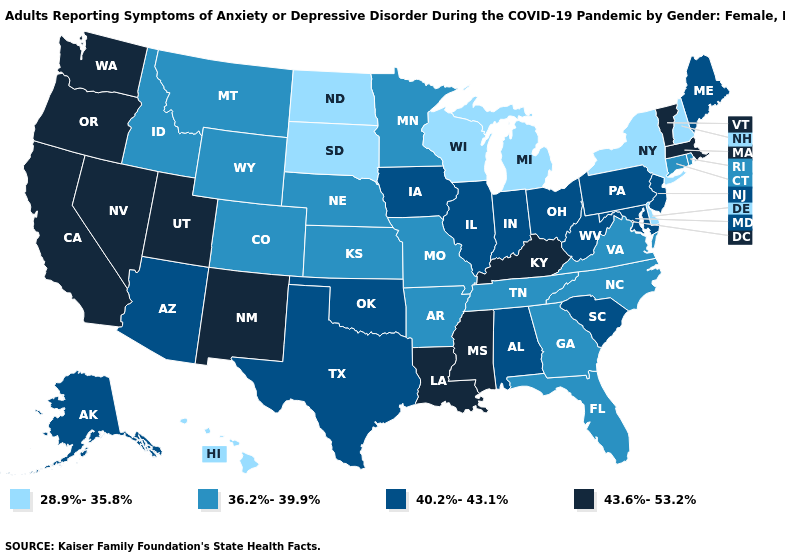Name the states that have a value in the range 28.9%-35.8%?
Keep it brief. Delaware, Hawaii, Michigan, New Hampshire, New York, North Dakota, South Dakota, Wisconsin. Name the states that have a value in the range 43.6%-53.2%?
Be succinct. California, Kentucky, Louisiana, Massachusetts, Mississippi, Nevada, New Mexico, Oregon, Utah, Vermont, Washington. Name the states that have a value in the range 43.6%-53.2%?
Give a very brief answer. California, Kentucky, Louisiana, Massachusetts, Mississippi, Nevada, New Mexico, Oregon, Utah, Vermont, Washington. Does Montana have a higher value than New Jersey?
Give a very brief answer. No. What is the value of Louisiana?
Concise answer only. 43.6%-53.2%. Name the states that have a value in the range 28.9%-35.8%?
Short answer required. Delaware, Hawaii, Michigan, New Hampshire, New York, North Dakota, South Dakota, Wisconsin. What is the value of Nevada?
Answer briefly. 43.6%-53.2%. Does the map have missing data?
Give a very brief answer. No. What is the value of Idaho?
Be succinct. 36.2%-39.9%. Name the states that have a value in the range 43.6%-53.2%?
Be succinct. California, Kentucky, Louisiana, Massachusetts, Mississippi, Nevada, New Mexico, Oregon, Utah, Vermont, Washington. Among the states that border Connecticut , which have the lowest value?
Keep it brief. New York. What is the value of Pennsylvania?
Short answer required. 40.2%-43.1%. Does Washington have the highest value in the West?
Keep it brief. Yes. How many symbols are there in the legend?
Concise answer only. 4. Does the first symbol in the legend represent the smallest category?
Concise answer only. Yes. 